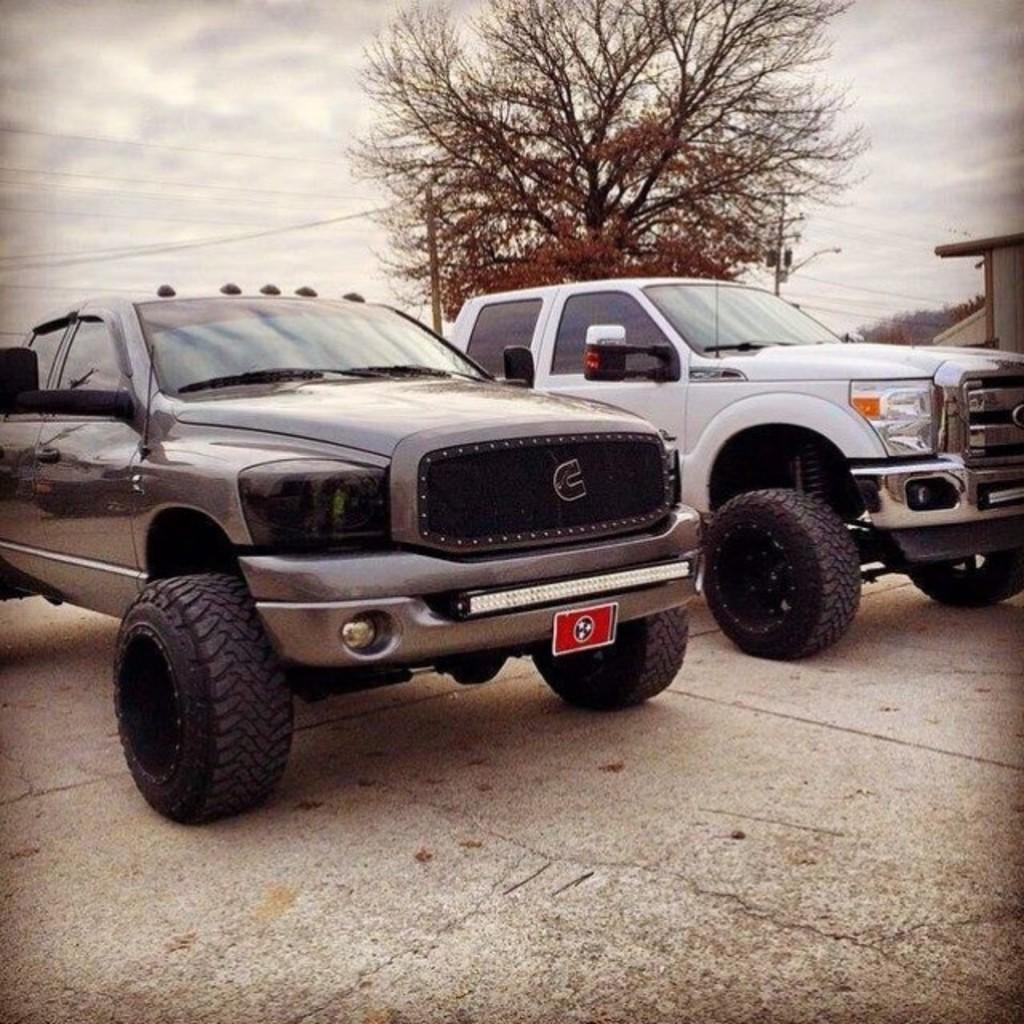What type of objects are on the floor in the image? There are motor vehicles on the floor in the image. What structures can be seen in the image? There are buildings in the image. What utility infrastructure is present in the image? Electric poles and electric cables are visible in the image. What type of natural elements are present in the image? Trees arees are present in the image. What part of the natural environment is visible in the image? The sky is visible in the image, and clouds are present in the sky. What type of paste is being used to hold the buildings together in the image? There is no indication of any paste being used to hold the buildings together in the image. Can you describe the wilderness area visible in the image? There is no wilderness area visible in the image; it features motor vehicles, buildings, electric poles, electric cables, trees, and the sky. 